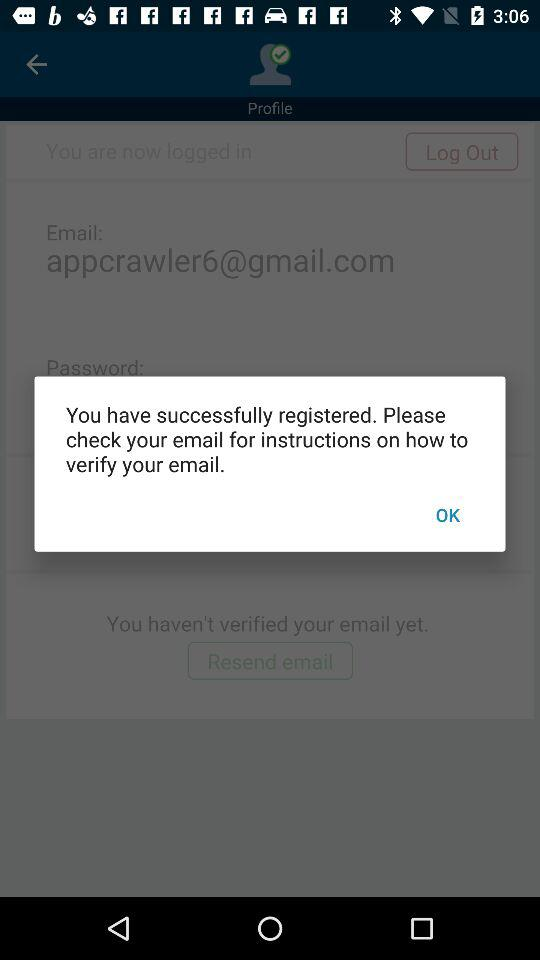What should I do to check for the instructions? You should check your email for the instructions. 